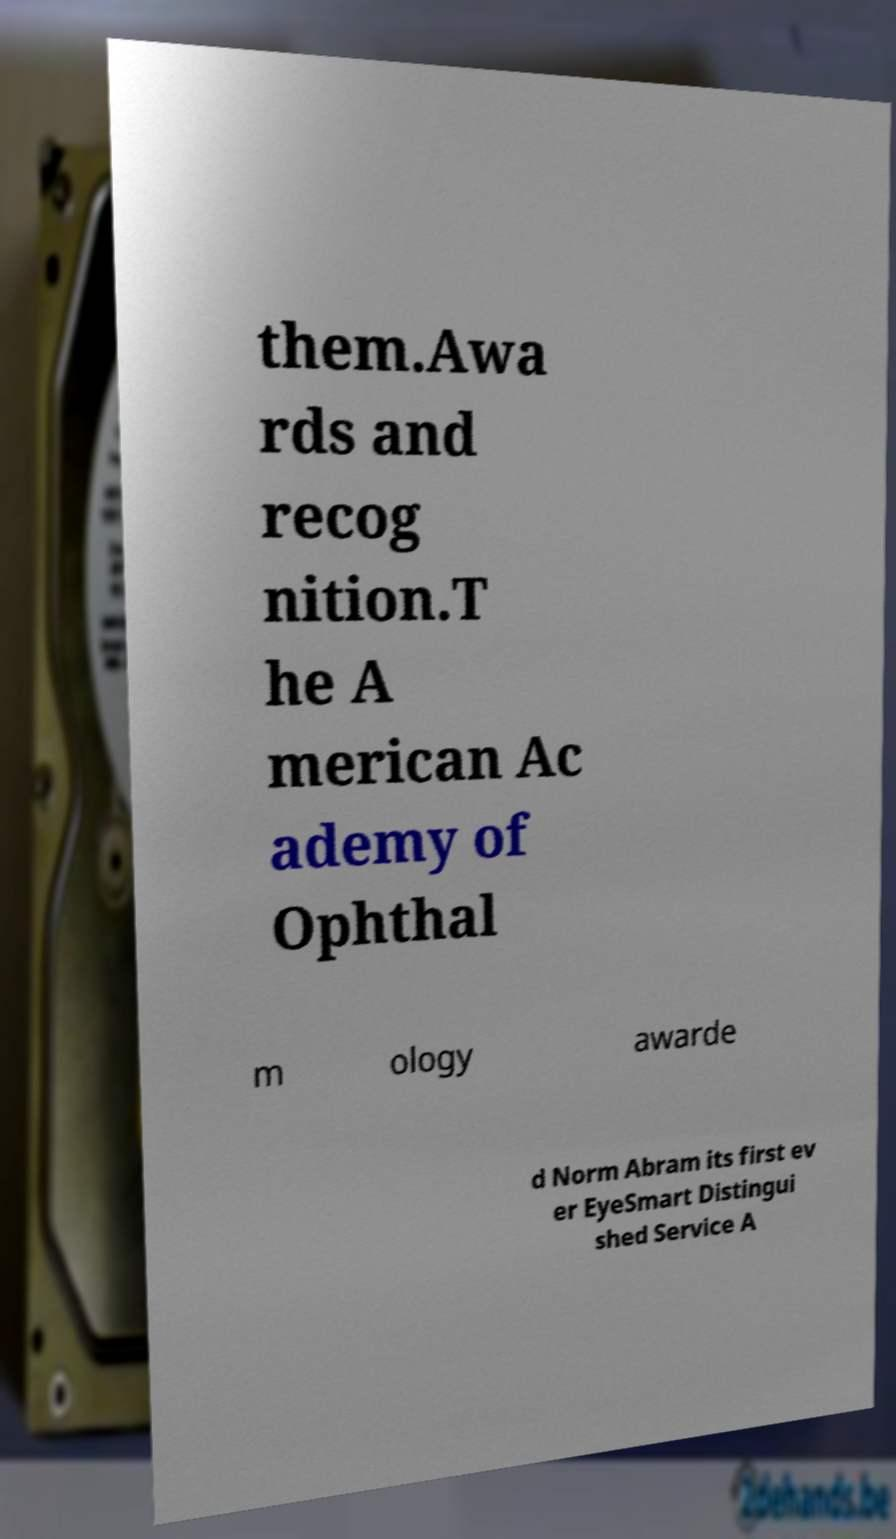I need the written content from this picture converted into text. Can you do that? them.Awa rds and recog nition.T he A merican Ac ademy of Ophthal m ology awarde d Norm Abram its first ev er EyeSmart Distingui shed Service A 